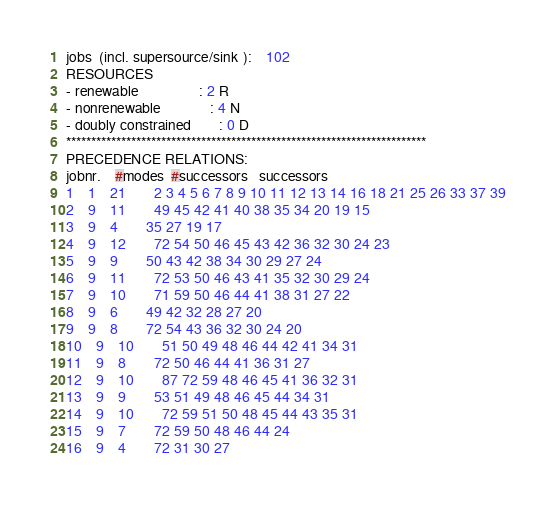Convert code to text. <code><loc_0><loc_0><loc_500><loc_500><_ObjectiveC_>jobs  (incl. supersource/sink ):	102
RESOURCES
- renewable                 : 2 R
- nonrenewable              : 4 N
- doubly constrained        : 0 D
************************************************************************
PRECEDENCE RELATIONS:
jobnr.    #modes  #successors   successors
1	1	21		2 3 4 5 6 7 8 9 10 11 12 13 14 16 18 21 25 26 33 37 39 
2	9	11		49 45 42 41 40 38 35 34 20 19 15 
3	9	4		35 27 19 17 
4	9	12		72 54 50 46 45 43 42 36 32 30 24 23 
5	9	9		50 43 42 38 34 30 29 27 24 
6	9	11		72 53 50 46 43 41 35 32 30 29 24 
7	9	10		71 59 50 46 44 41 38 31 27 22 
8	9	6		49 42 32 28 27 20 
9	9	8		72 54 43 36 32 30 24 20 
10	9	10		51 50 49 48 46 44 42 41 34 31 
11	9	8		72 50 46 44 41 36 31 27 
12	9	10		87 72 59 48 46 45 41 36 32 31 
13	9	9		53 51 49 48 46 45 44 34 31 
14	9	10		72 59 51 50 48 45 44 43 35 31 
15	9	7		72 59 50 48 46 44 24 
16	9	4		72 31 30 27 </code> 